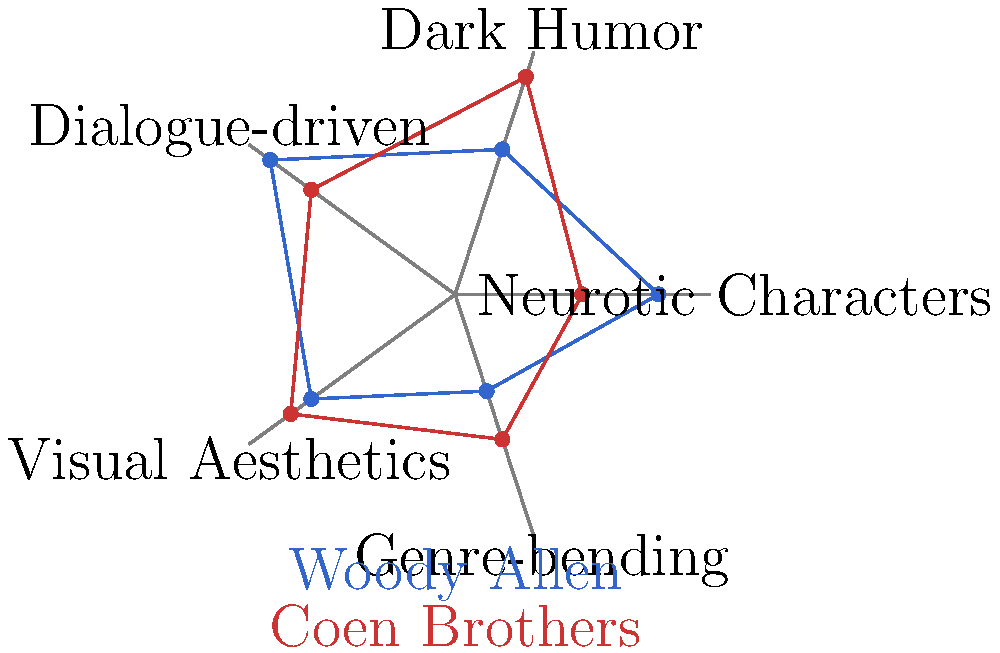Based on the radar chart comparing the visual styles of Woody Allen and the Coen Brothers, which filmmaker(s) tend to incorporate more genre-bending elements in their work? To answer this question, we need to analyze the radar chart:

1. The chart compares five aspects of filmmaking style for Woody Allen and the Coen Brothers.
2. Each aspect is represented by an axis on the pentagonal chart.
3. The "Genre-bending" axis is located at the bottom right of the pentagon.
4. We need to compare the points on this axis for both filmmakers:
   - Woody Allen's point (blue) is closer to the center, indicating a lower score.
   - The Coen Brothers' point (red) is further from the center, indicating a higher score.
5. A higher score in "Genre-bending" suggests more frequent use of this element in their films.
6. The Coen Brothers' score is visibly higher than Woody Allen's on this axis.

Therefore, based on this chart, the Coen Brothers tend to incorporate more genre-bending elements in their work compared to Woody Allen.
Answer: The Coen Brothers 